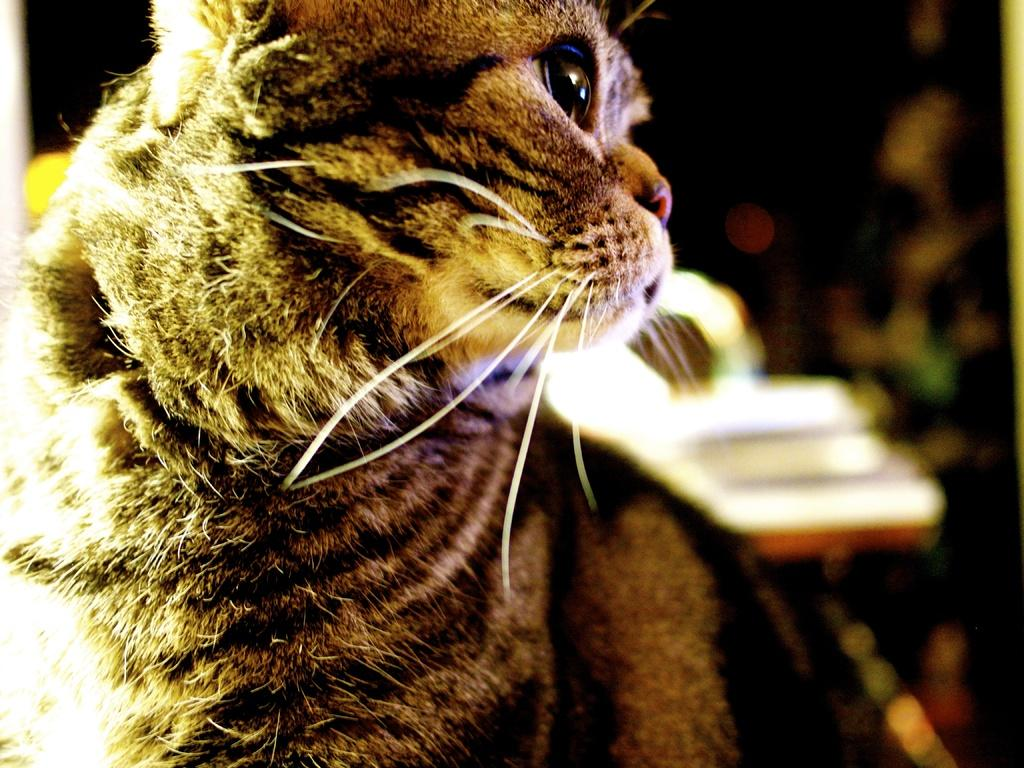What type of animal is in the image? There is a cat in the image. Can you describe the background of the image? The background of the image is blurry. What type of feather can be seen in the image? There is no feather present in the image; it features a cat and a blurry background. 